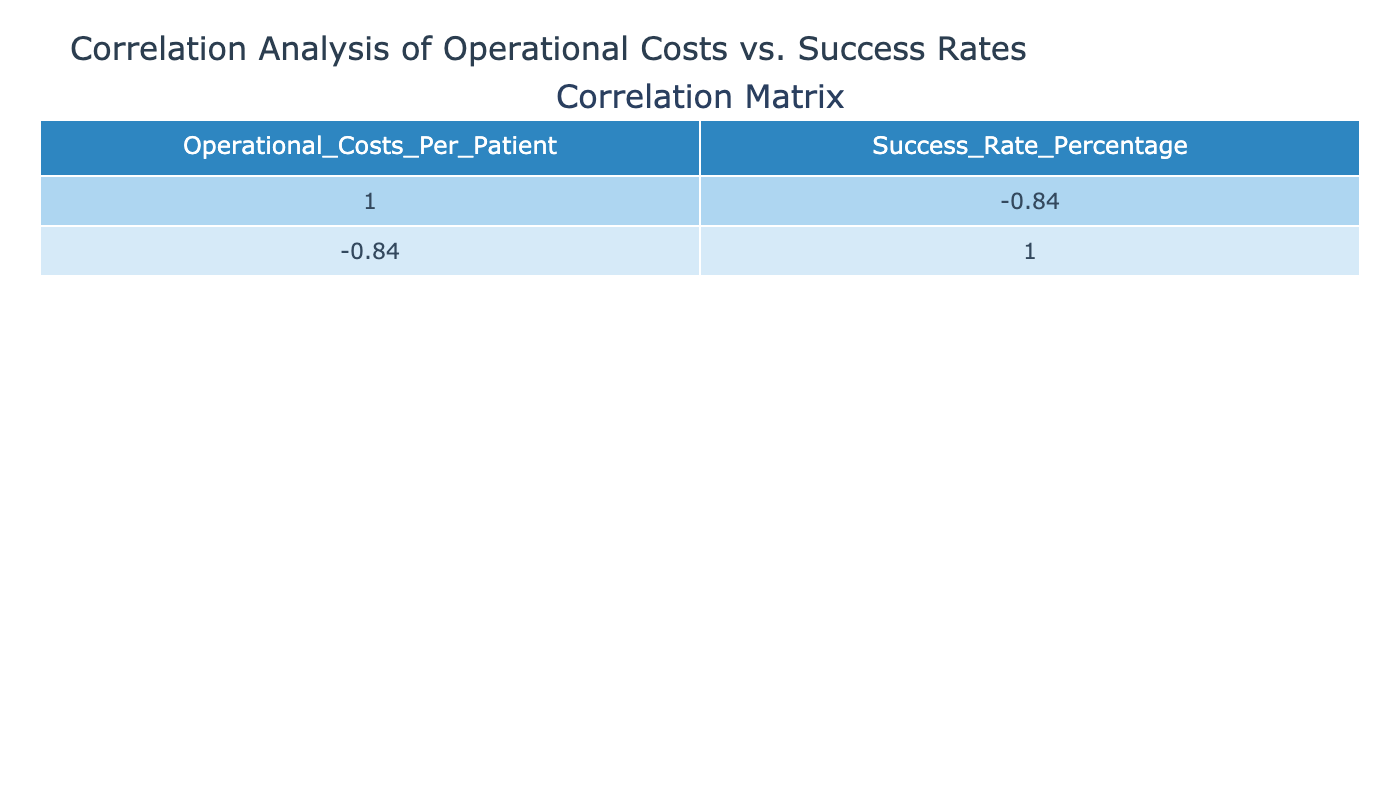What is the operational cost per patient for Orthopedics? The operational cost for Orthopedics is provided directly in the table. Under the Orthopedics specialization, the value listed is 12000.
Answer: 12000 Which specialization has the highest success rate percentage? To find the highest success rate, I will look through the success rate percentages listed for each specialization. The highest value is 92, associated with Pediatrics.
Answer: Pediatrics Is there a specialization with an operational cost under 10000? The table shows the operational costs for each specialization, and upon review, the lowest value is 9000 for Emergency Medicine, indicating there is indeed a specialization with operational costs under 10000.
Answer: Yes What is the difference in success rates between Cardiology and Oncology? The success rates are listed as 89 for Cardiology and 75 for Oncology. To find the difference, I subtract the two success rates: 89 - 75 = 14.
Answer: 14 What is the average operational cost per patient for the listed specializations? To obtain the average, I need to sum the operational costs for all specializations: 15000 + 12000 + 25000 + 11000 + 20000 + 16000 + 9000 + 13000 + 14000 + 15500 = 130500. There are 10 specializations, so the average is 130500 / 10 = 13050.
Answer: 13050 Is the operational cost per patient directly related to the success rate percentage? To determine if there is a direct relationship, I will consider the correlation coefficient from the table. A value close to 1 or -1 indicates a strong relationship. Since the correlation is likely negative, it implies that higher operational costs may be associated with lower success rates.
Answer: No Which two specializations have operational costs that are closest in value? By comparing each specialization's operational costs, I will look for the smallest difference. The closest values are for Urology (15500) and Ophthalmology (14000), with a difference of 1500.
Answer: Urology and Ophthalmology What is the minimum success rate percentage among the specializations? The success rates listed are 89, 85, 75, 92, 80, 87, 90, 83, 88, and 82. The minimum value among these is 75, associated with Oncology.
Answer: 75 If the operational cost for Gastroenterology is reduced by 2000, what would be the new operational cost per patient? The current operational cost for Gastroenterology is 16000. If reduced by 2000, the calculation would be 16000 - 2000 = 14000.
Answer: 14000 